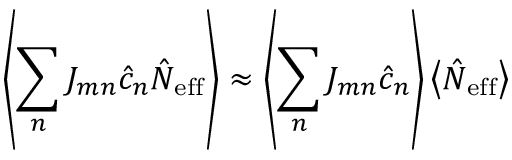Convert formula to latex. <formula><loc_0><loc_0><loc_500><loc_500>\left \langle \sum _ { n } J _ { m n } \hat { c } _ { n } \hat { N } _ { e f f } \right \rangle \approx \left \langle \sum _ { n } J _ { m n } \hat { c } _ { n } \right \rangle \left \langle \hat { N } _ { e f f } \right \rangle</formula> 